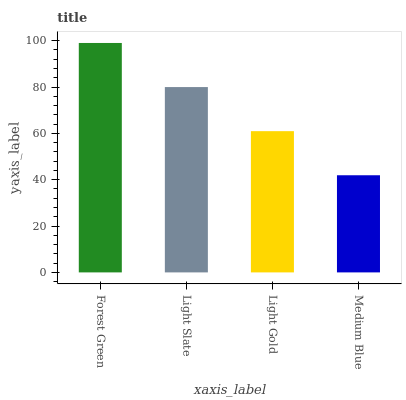Is Medium Blue the minimum?
Answer yes or no. Yes. Is Forest Green the maximum?
Answer yes or no. Yes. Is Light Slate the minimum?
Answer yes or no. No. Is Light Slate the maximum?
Answer yes or no. No. Is Forest Green greater than Light Slate?
Answer yes or no. Yes. Is Light Slate less than Forest Green?
Answer yes or no. Yes. Is Light Slate greater than Forest Green?
Answer yes or no. No. Is Forest Green less than Light Slate?
Answer yes or no. No. Is Light Slate the high median?
Answer yes or no. Yes. Is Light Gold the low median?
Answer yes or no. Yes. Is Medium Blue the high median?
Answer yes or no. No. Is Forest Green the low median?
Answer yes or no. No. 